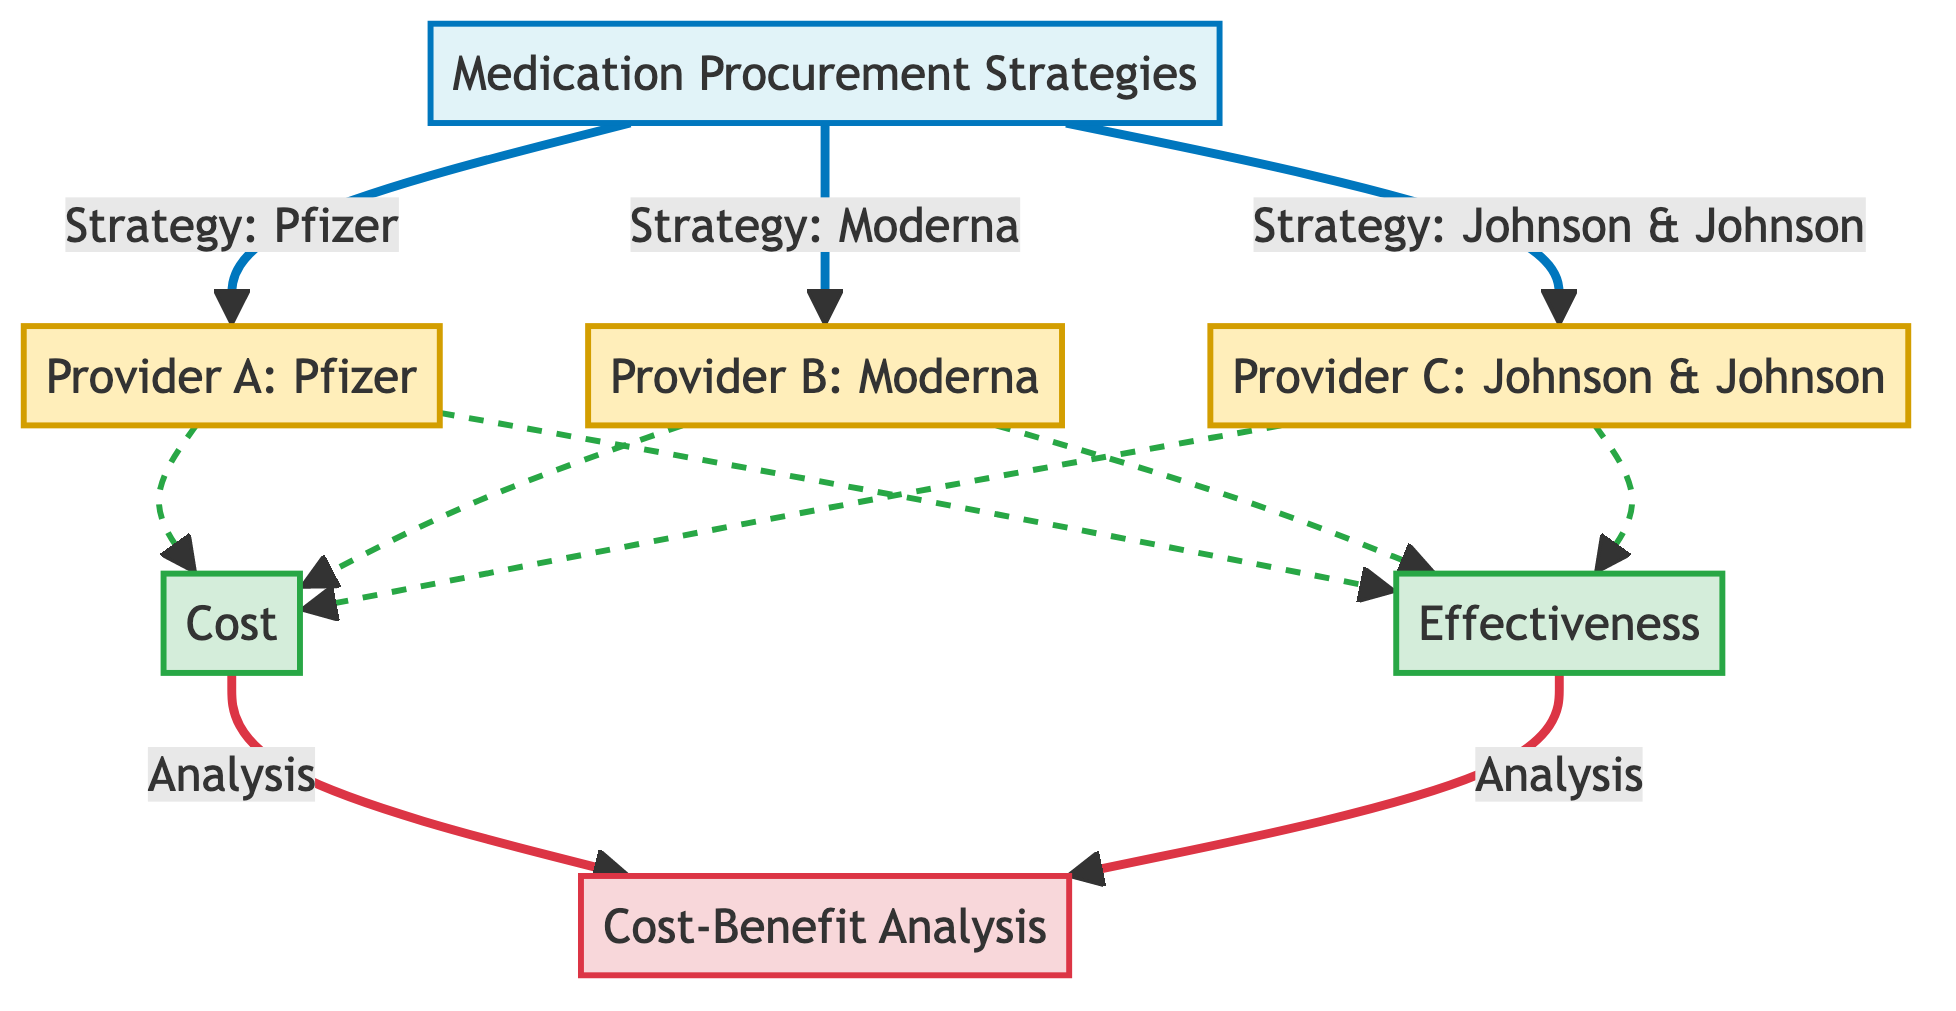What are the three providers listed in the diagram? The diagram shows three distinct providers labeled as Provider A, Provider B, and Provider C, which correspond to Pfizer, Moderna, and Johnson & Johnson.
Answer: Pfizer, Moderna, Johnson & Johnson Which strategy is associated with Provider B? Provider B, which is Moderna, connects directly with the medication procurement strategy outlined at the top of the diagram, indicating that the strategy utilized is for Moderna.
Answer: Strategy: Moderna How many metrics are presented in the diagram? There are two metrics listed in the diagram: Cost and Effectiveness. Both metrics are connected to each provider, indicating they are assessed for all three.
Answer: 2 What is the final analysis label in the diagram? The last node in the flow of the diagram is labeled as Cost-Benefit Analysis, which aggregates the evaluation of cost and effectiveness for the providers.
Answer: Cost-Benefit Analysis Which provider is linked to the lowest effectiveness? Based on the diagram flow, all providers lead to effectiveness but requires analysis. If effectiveness data is provided alongside this, one could deduce which is lowest, but the diagram as is does not specify. Hence, we cannot answer.
Answer: Not specified How does the cost metric relate to the analysis node? The cost metric and the effectiveness metric both feed into the analysis node labeled as Cost-Benefit Analysis, indicating that both factors are necessary for a comprehensive evaluation of the provider strategies.
Answer: Direct input What shapes define the providers in the diagram? Each provider in the diagram is represented with a specific fill color and stroke as defined; Pfizer, Moderna, and Johnson & Johnson are marked with a fill color denoting them as providers.
Answer: Rectangles with specific coloring Which strategy corresponds to Johnson & Johnson? Johnson & Johnson is referred to as Provider C in the diagram, and the corresponding strategy is connected similarly to Pfizer and Moderna under medication procurement strategies.
Answer: Strategy: Johnson & Johnson 